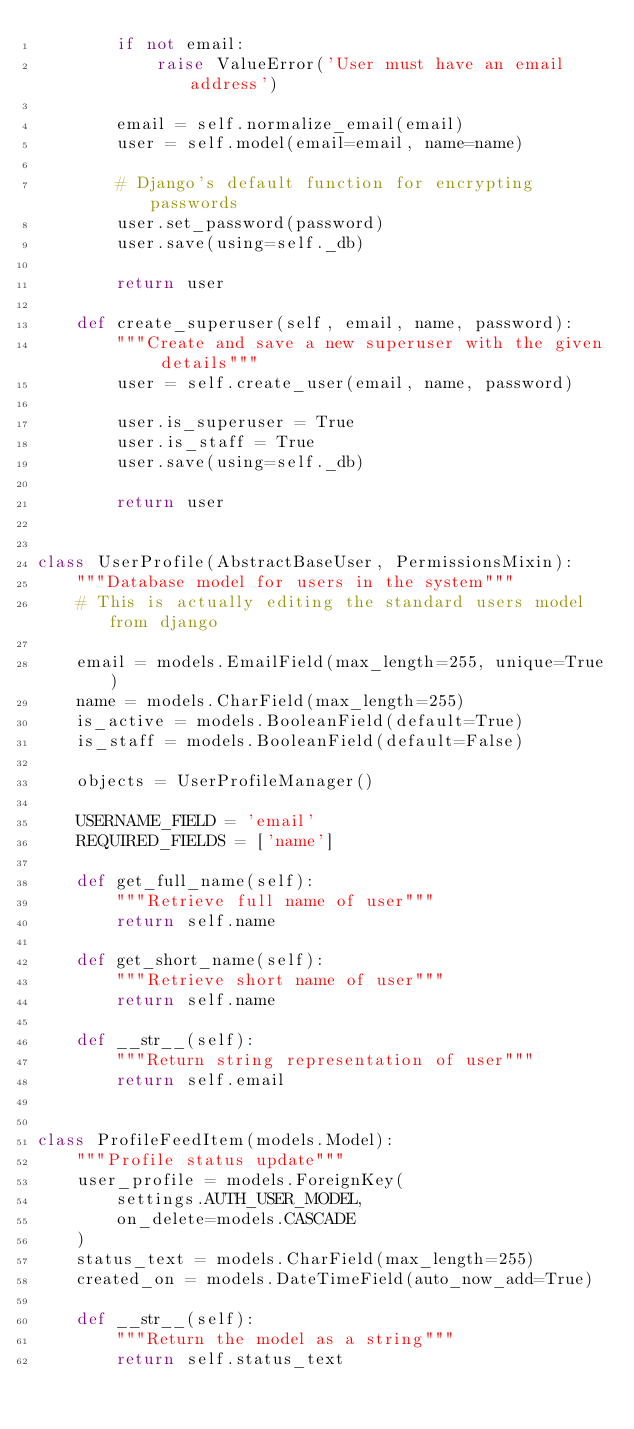Convert code to text. <code><loc_0><loc_0><loc_500><loc_500><_Python_>        if not email:
            raise ValueError('User must have an email address')

        email = self.normalize_email(email)
        user = self.model(email=email, name=name)

        # Django's default function for encrypting passwords
        user.set_password(password)
        user.save(using=self._db)

        return user

    def create_superuser(self, email, name, password):
        """Create and save a new superuser with the given details"""
        user = self.create_user(email, name, password)

        user.is_superuser = True
        user.is_staff = True
        user.save(using=self._db)

        return user


class UserProfile(AbstractBaseUser, PermissionsMixin):
    """Database model for users in the system"""
    # This is actually editing the standard users model from django

    email = models.EmailField(max_length=255, unique=True)
    name = models.CharField(max_length=255)
    is_active = models.BooleanField(default=True)
    is_staff = models.BooleanField(default=False)

    objects = UserProfileManager()

    USERNAME_FIELD = 'email'
    REQUIRED_FIELDS = ['name']

    def get_full_name(self):
        """Retrieve full name of user"""
        return self.name

    def get_short_name(self):
        """Retrieve short name of user"""
        return self.name

    def __str__(self):
        """Return string representation of user"""
        return self.email


class ProfileFeedItem(models.Model):
    """Profile status update"""
    user_profile = models.ForeignKey(
        settings.AUTH_USER_MODEL,
        on_delete=models.CASCADE
    )
    status_text = models.CharField(max_length=255)
    created_on = models.DateTimeField(auto_now_add=True)

    def __str__(self):
        """Return the model as a string"""
        return self.status_text
</code> 